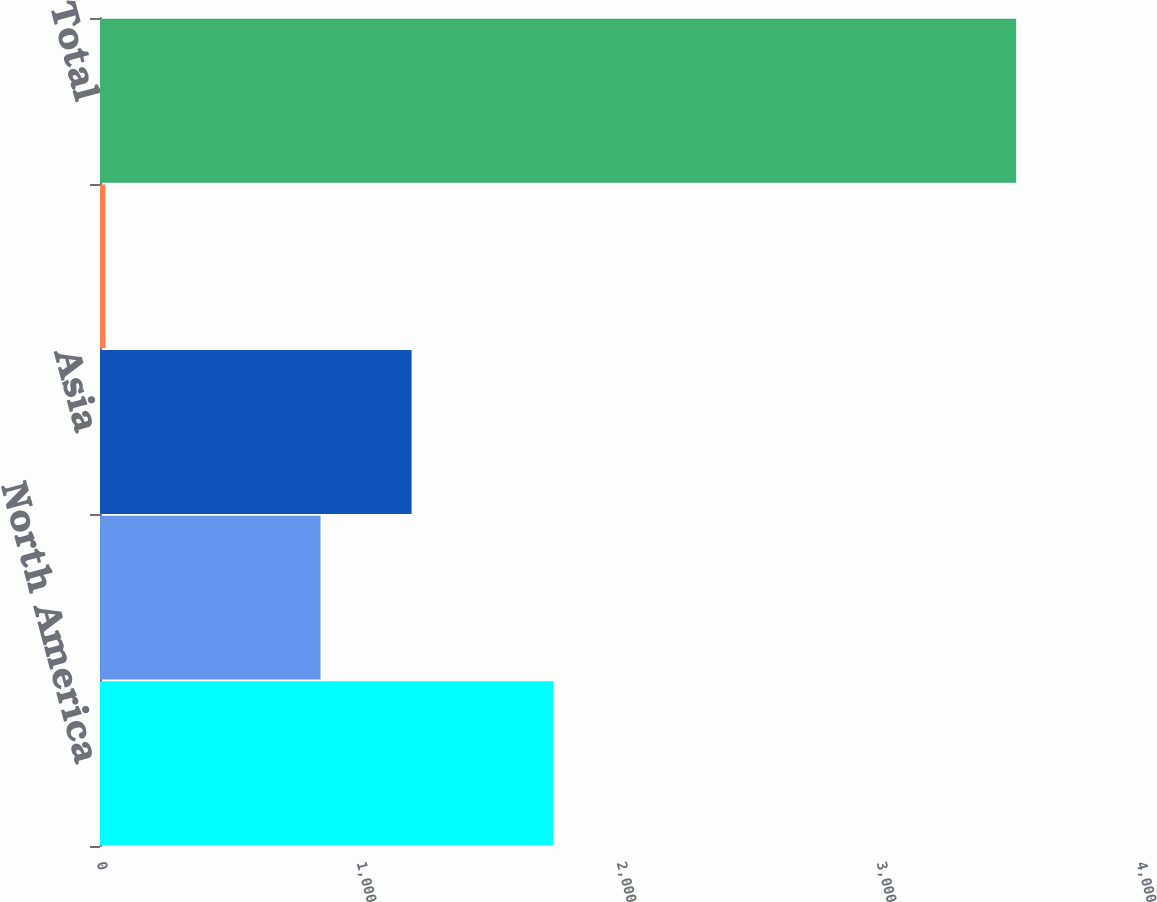<chart> <loc_0><loc_0><loc_500><loc_500><bar_chart><fcel>North America<fcel>Europe<fcel>Asia<fcel>Other<fcel>Total<nl><fcel>1745<fcel>848.1<fcel>1198.35<fcel>21.2<fcel>3523.7<nl></chart> 